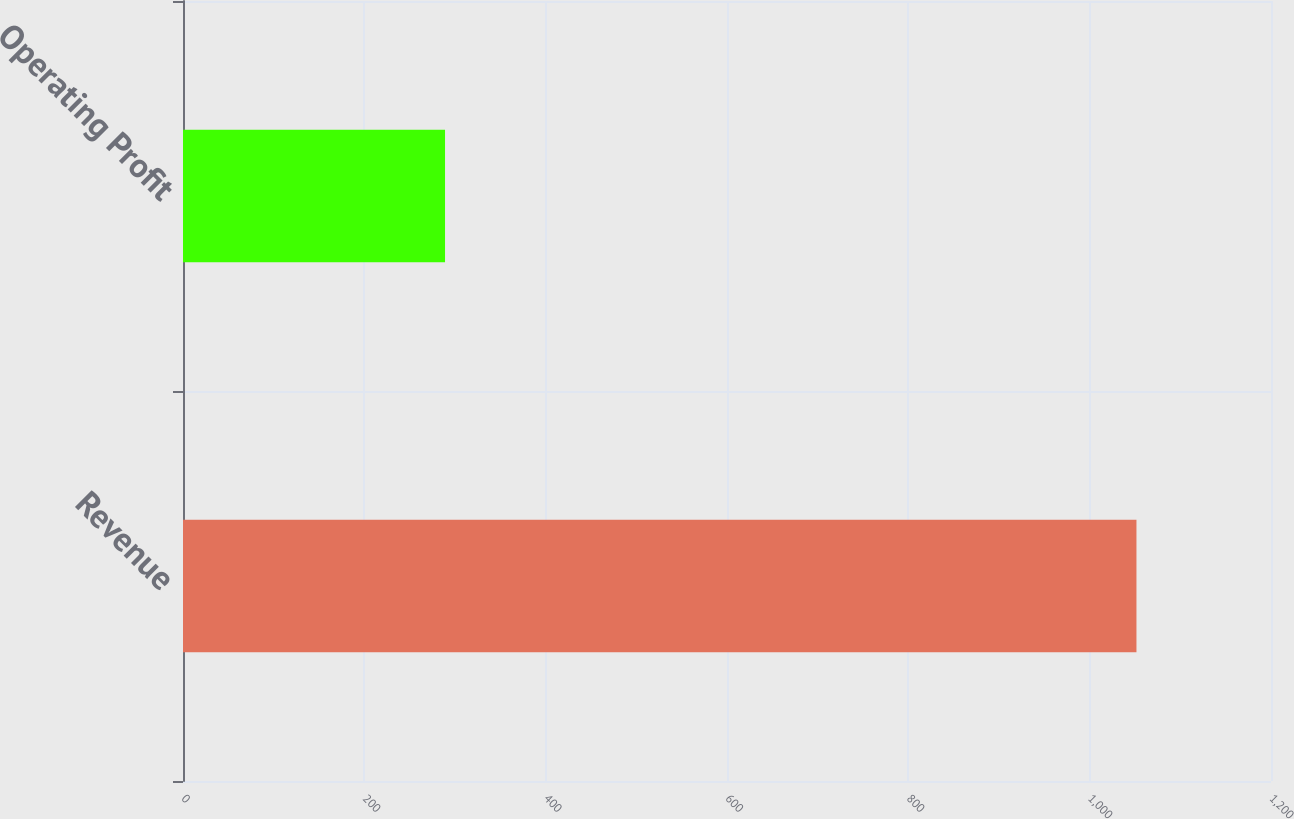<chart> <loc_0><loc_0><loc_500><loc_500><bar_chart><fcel>Revenue<fcel>Operating Profit<nl><fcel>1051.6<fcel>289<nl></chart> 